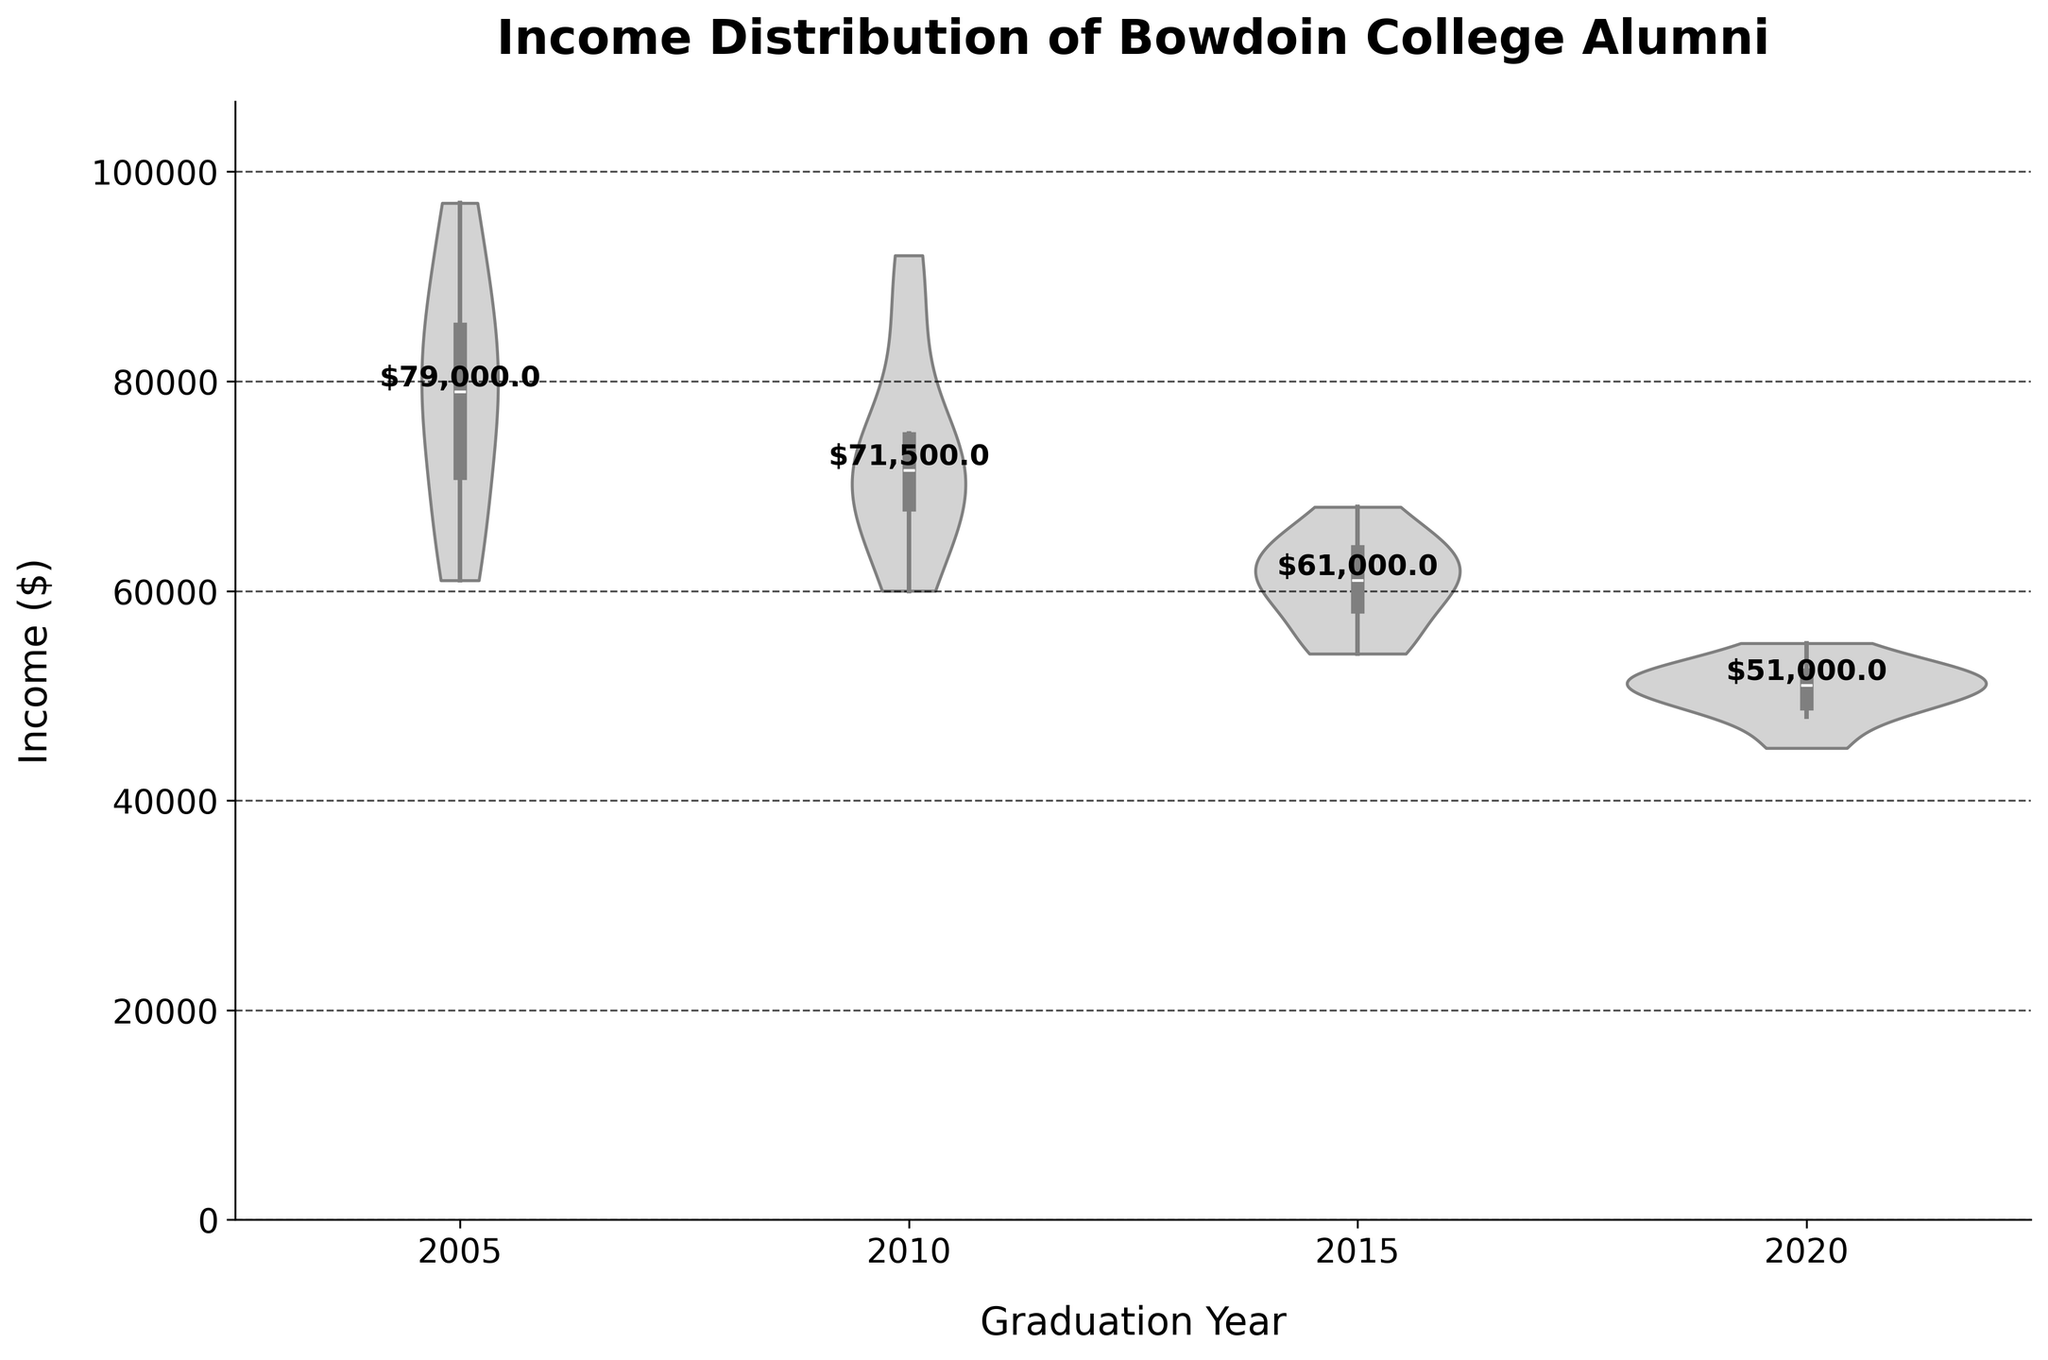What is the title of the chart? The title of the chart is usually located at the top of the figure and provides a summary of what the data visualization is about. In this case, the title is "Income Distribution of Bowdoin College Alumni," indicating that the chart visualizes income data of alumni by their graduation year.
Answer: Income Distribution of Bowdoin College Alumni What years are shown on the x-axis? The x-axis displays different graduation years, which are the categories for which the income distributions are plotted. Here, the distinct years are 2005, 2010, 2015, and 2020.
Answer: 2005, 2010, 2015, 2020 Which graduation year has the highest median income based on the chart? The median income for each graduation year is highlighted with a text label on the chart. By reading the labels, we can identify that the class of 2005 has the highest median income, which is $78,000.
Answer: 2005 What is the approximate income range for the class of 2020? The violin plot for each graduation year extends from the minimum to the maximum value of that group's income. For the class of 2020, the plot stretches from approximately $45,000 to $55,000, which gives us the income range.
Answer: $45,000 to $55,000 Compare the income distributions for the classes of 2010 and 2015. Which has the broader range? To compare the income distributions' range, we examine the extent of the violin plots for both years. The 2010 violin plot ranges roughly from $60,000 to $92,000, whereas the 2015 plot ranges from around $54,000 to $68,000. Thus, the 2010 class has a broader range.
Answer: 2010 How do the median incomes for 2010 and 2015 compare to each other? The median income for each graduation year is labeled on the chart. For 2010, the median income is $71,000, and for 2015, the median is $61,000. This indicates that the 2010 median is higher than the 2015 median.
Answer: 2010 has a higher median What can be said about the spread of the income distribution for the class of 2005? The violin plot for 2005 is relatively wide, indicating a broader spread of income data points. Additionally, the box plot overlay within the violin plot shows the interquartile range and whiskers extending further, which supports the visualization of a more varied income distribution.
Answer: Broader spread Is there an observable trend in median incomes across the years? By examining the chart, we notice the labeled median incomes for each year: 2005 ($78,000), 2010 ($71,000), 2015 ($61,000), and 2020 ($51,000). This indicates a decreasing trend in median incomes from earlier to more recent graduation years.
Answer: Decreasing trend What is the significance of the box plot overlay on the violin plot? The box plot overlay within the violin plot represents the interquartile range (IQR), median, and potential outliers. It adds statistical detail about the income distribution by showing where most of the values lie and the central tendency.
Answer: Shows IQR, median, and outliers 